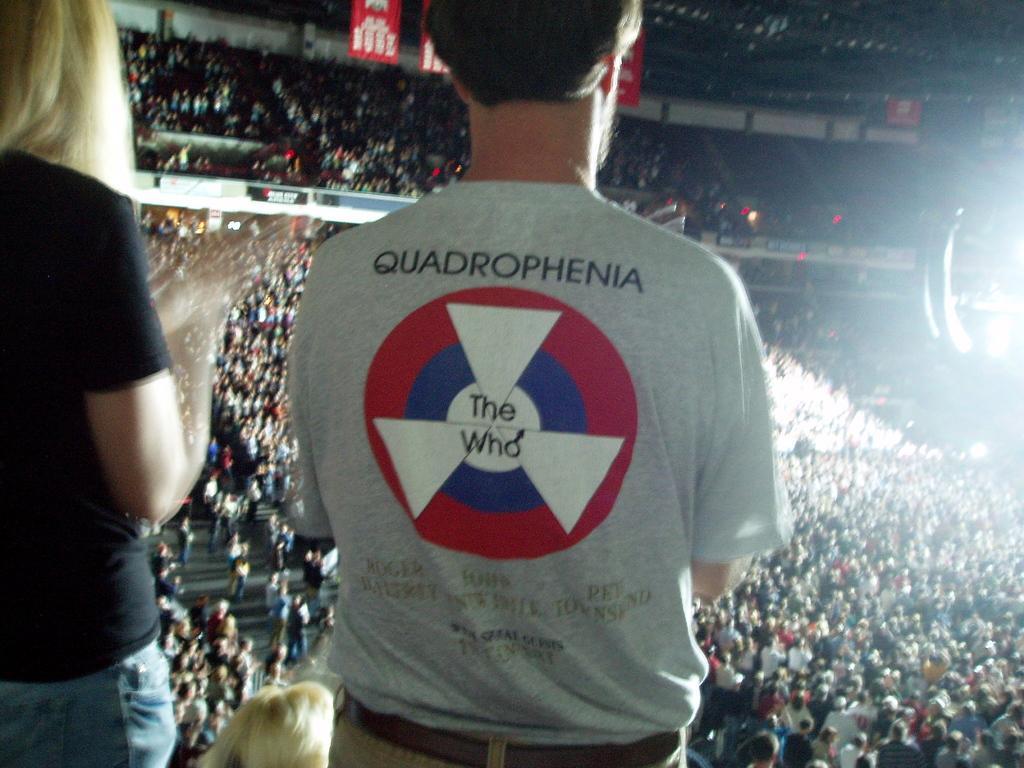Can you describe this image briefly? We can see a man and a woman standing. Man is wearing a t shirt with a logo and something written on that. In the back there is a crowd, banners and light. 